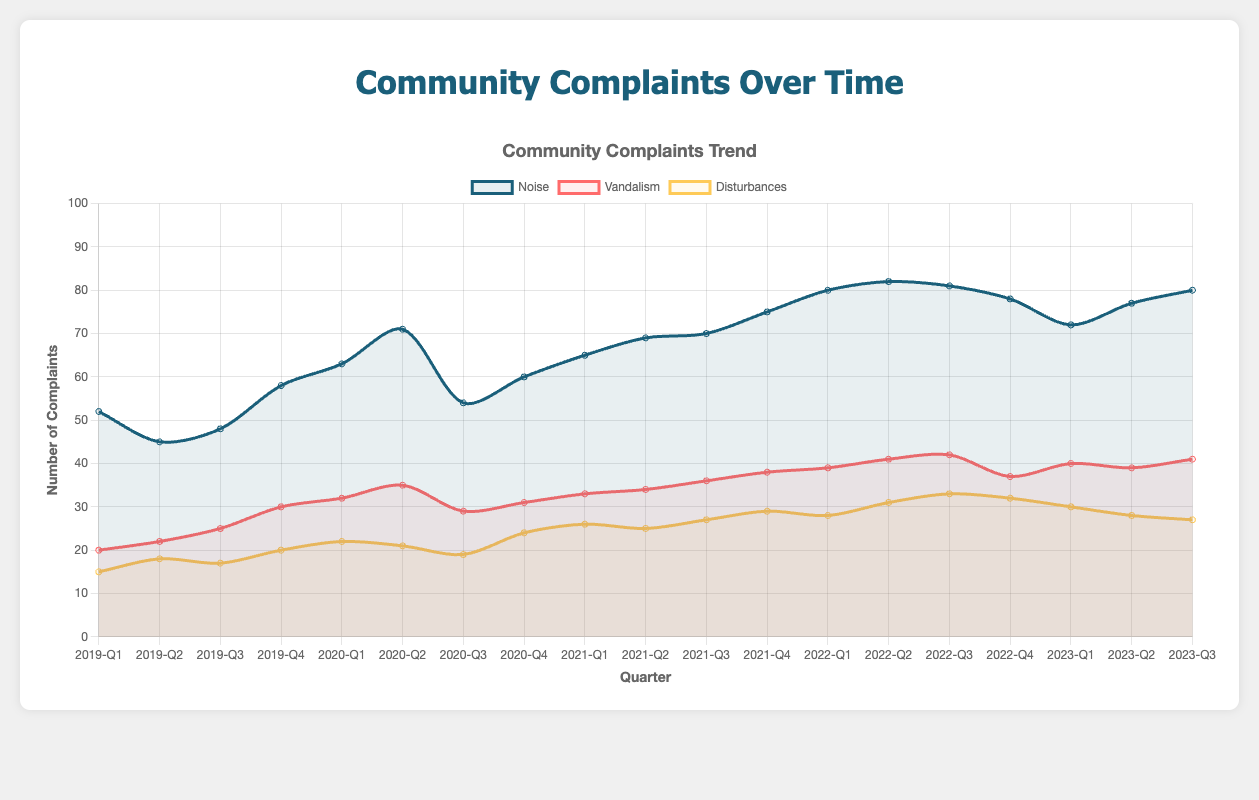What quarter had the highest number of Noise complaints? From the chart, we can see the highest peak in the Noise complaints line. The peak is in "2022-Q2" with 82 complaints.
Answer: 2022-Q2 How many Noise complaints were there in total in 2020? Sum the Noise complaints for each quarter in 2020: 63 + 71 + 54 + 60 = 248
Answer: 248 Compare Noise and Vandalism complaints for 2023-Q1. Which one is higher and by how much? In 2023-Q1, Noise complaints were 72 and Vandalism complaints were 40. The difference is 72 - 40 = 32, which means Noise complaints were higher by 32.
Answer: Noise by 32 What is the trend of Disturbance complaints from 2020-Q1 to 2020-Q4? In 2020, the Disturbance complaints are as follows: 22, 21, 19, 24. We see a slight decrease from Q1 (22) to Q3 (19), then an increase in Q4 (24). Overall, the trend includes a decrease followed by an increase.
Answer: Decrease then increase What is the average number of Vandalism complaints from 2019-Q1 to 2019-Q4? Sum the Vandalism complaints for each quarter in 2019: 20 + 22 + 25 + 30 = 97. Divide by the number of quarters: 97 / 4 = 24.25
Answer: 24.25 Which category had the most stable number of complaints over the entire period, and how can you tell? The Vandalism complaints line shows less fluctuation compared to Noise and Disturbances, which have more peaks and valleys. This indicates that Vandalism complaints are the most stable.
Answer: Vandalism Which quarter observed the lowest number of Disturbance complaints and what is the count? By observing the Disturbances line, the lowest point appears in "2019-Q1" with 15 complaints.
Answer: 2019-Q1 with 15 complaints How did the number of Noise complaints in 2021-Q4 compare to 2020-Q4? Noise complaints in 2021-Q4 were 75, and in 2020-Q4 they were 60. The difference is 75 - 60 = 15, showing an increase of 15 complaints from 2020-Q4 to 2021-Q4.
Answer: Increased by 15 Between which quarters did the Vandalism complaints see the largest increase? The largest increase in Vandalism complaints can be seen from "2019-Q3" to "2019-Q4", where it increased from 25 to 30, an increase of 5 complaints.
Answer: 2019-Q3 to 2019-Q4 What is the total number of Disturbance complaints in 2021? Sum the Disturbance complaints for each quarter in 2021: 26 + 25 + 27 + 29 = 107
Answer: 107 